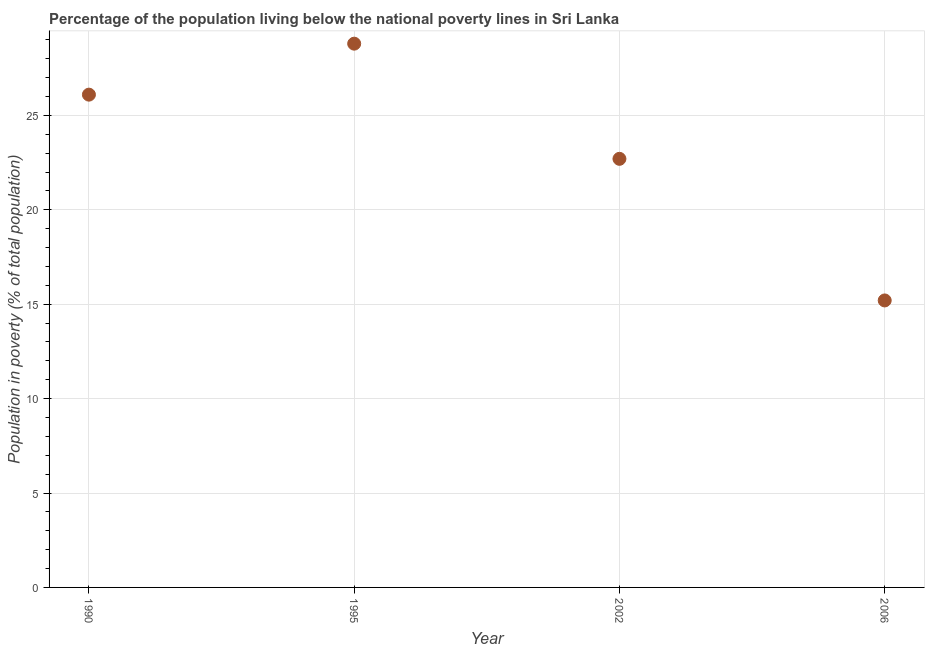What is the percentage of population living below poverty line in 2002?
Your answer should be compact. 22.7. Across all years, what is the maximum percentage of population living below poverty line?
Your response must be concise. 28.8. In which year was the percentage of population living below poverty line maximum?
Your response must be concise. 1995. What is the sum of the percentage of population living below poverty line?
Your answer should be compact. 92.8. What is the difference between the percentage of population living below poverty line in 1995 and 2002?
Give a very brief answer. 6.1. What is the average percentage of population living below poverty line per year?
Your answer should be compact. 23.2. What is the median percentage of population living below poverty line?
Offer a very short reply. 24.4. What is the ratio of the percentage of population living below poverty line in 1995 to that in 2006?
Provide a succinct answer. 1.89. Is the percentage of population living below poverty line in 1995 less than that in 2006?
Keep it short and to the point. No. Is the difference between the percentage of population living below poverty line in 1990 and 1995 greater than the difference between any two years?
Your answer should be very brief. No. What is the difference between the highest and the second highest percentage of population living below poverty line?
Offer a terse response. 2.7. What is the difference between the highest and the lowest percentage of population living below poverty line?
Keep it short and to the point. 13.6. In how many years, is the percentage of population living below poverty line greater than the average percentage of population living below poverty line taken over all years?
Give a very brief answer. 2. How many dotlines are there?
Give a very brief answer. 1. Are the values on the major ticks of Y-axis written in scientific E-notation?
Your answer should be compact. No. Does the graph contain grids?
Your response must be concise. Yes. What is the title of the graph?
Ensure brevity in your answer.  Percentage of the population living below the national poverty lines in Sri Lanka. What is the label or title of the Y-axis?
Your response must be concise. Population in poverty (% of total population). What is the Population in poverty (% of total population) in 1990?
Give a very brief answer. 26.1. What is the Population in poverty (% of total population) in 1995?
Offer a very short reply. 28.8. What is the Population in poverty (% of total population) in 2002?
Ensure brevity in your answer.  22.7. What is the difference between the Population in poverty (% of total population) in 1990 and 1995?
Give a very brief answer. -2.7. What is the difference between the Population in poverty (% of total population) in 1995 and 2002?
Your answer should be very brief. 6.1. What is the difference between the Population in poverty (% of total population) in 2002 and 2006?
Your response must be concise. 7.5. What is the ratio of the Population in poverty (% of total population) in 1990 to that in 1995?
Provide a succinct answer. 0.91. What is the ratio of the Population in poverty (% of total population) in 1990 to that in 2002?
Your answer should be compact. 1.15. What is the ratio of the Population in poverty (% of total population) in 1990 to that in 2006?
Give a very brief answer. 1.72. What is the ratio of the Population in poverty (% of total population) in 1995 to that in 2002?
Keep it short and to the point. 1.27. What is the ratio of the Population in poverty (% of total population) in 1995 to that in 2006?
Make the answer very short. 1.9. What is the ratio of the Population in poverty (% of total population) in 2002 to that in 2006?
Provide a short and direct response. 1.49. 